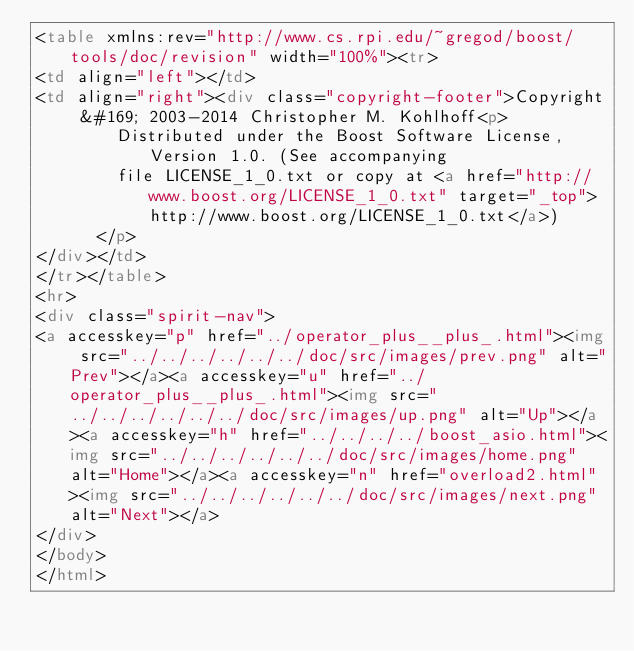<code> <loc_0><loc_0><loc_500><loc_500><_HTML_><table xmlns:rev="http://www.cs.rpi.edu/~gregod/boost/tools/doc/revision" width="100%"><tr>
<td align="left"></td>
<td align="right"><div class="copyright-footer">Copyright &#169; 2003-2014 Christopher M. Kohlhoff<p>
        Distributed under the Boost Software License, Version 1.0. (See accompanying
        file LICENSE_1_0.txt or copy at <a href="http://www.boost.org/LICENSE_1_0.txt" target="_top">http://www.boost.org/LICENSE_1_0.txt</a>)
      </p>
</div></td>
</tr></table>
<hr>
<div class="spirit-nav">
<a accesskey="p" href="../operator_plus__plus_.html"><img src="../../../../../../doc/src/images/prev.png" alt="Prev"></a><a accesskey="u" href="../operator_plus__plus_.html"><img src="../../../../../../doc/src/images/up.png" alt="Up"></a><a accesskey="h" href="../../../../boost_asio.html"><img src="../../../../../../doc/src/images/home.png" alt="Home"></a><a accesskey="n" href="overload2.html"><img src="../../../../../../doc/src/images/next.png" alt="Next"></a>
</div>
</body>
</html>
</code> 